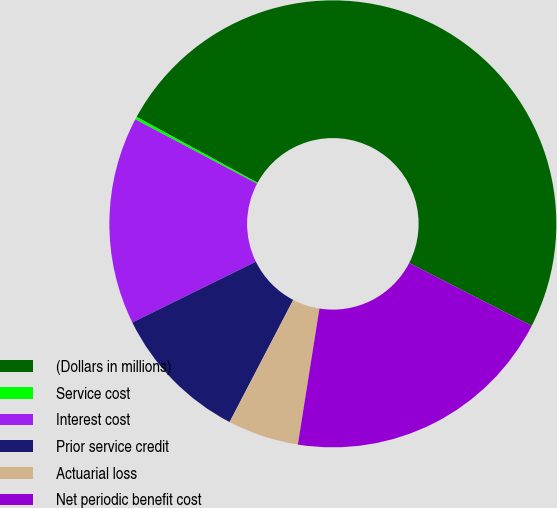Convert chart to OTSL. <chart><loc_0><loc_0><loc_500><loc_500><pie_chart><fcel>(Dollars in millions)<fcel>Service cost<fcel>Interest cost<fcel>Prior service credit<fcel>Actuarial loss<fcel>Net periodic benefit cost<nl><fcel>49.6%<fcel>0.2%<fcel>15.02%<fcel>10.08%<fcel>5.14%<fcel>19.96%<nl></chart> 